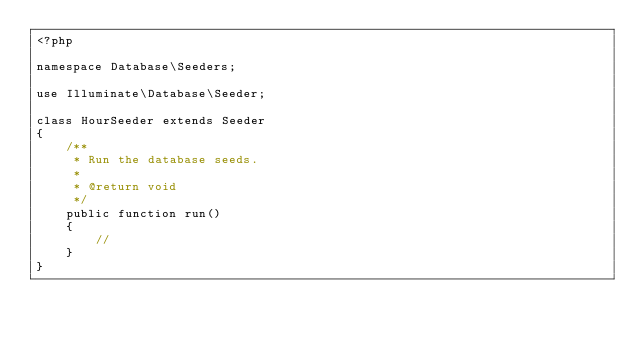<code> <loc_0><loc_0><loc_500><loc_500><_PHP_><?php

namespace Database\Seeders;

use Illuminate\Database\Seeder;

class HourSeeder extends Seeder
{
    /**
     * Run the database seeds.
     *
     * @return void
     */
    public function run()
    {
        //
    }
}
</code> 